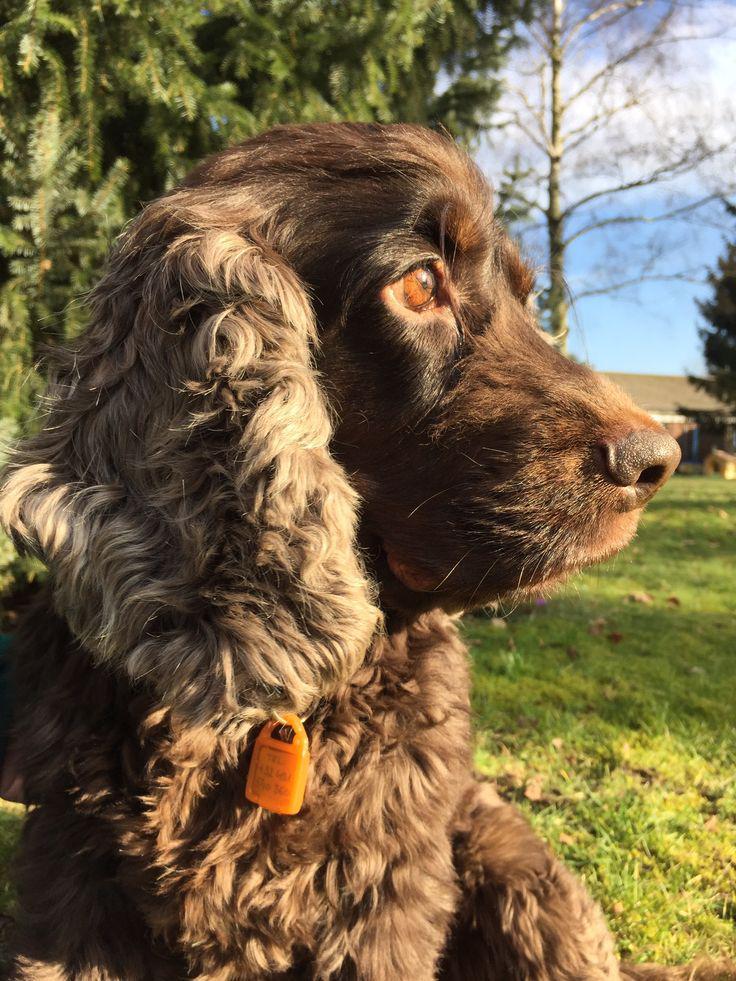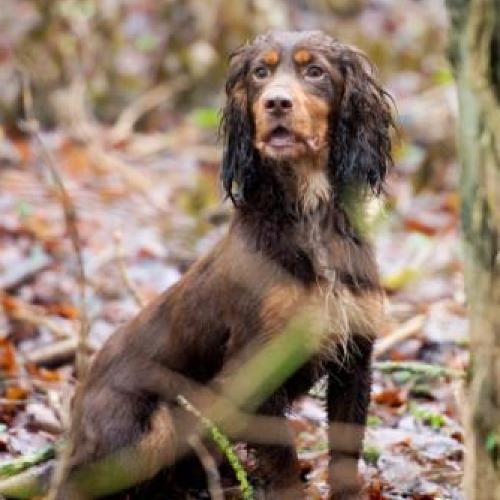The first image is the image on the left, the second image is the image on the right. Given the left and right images, does the statement "One image shows an upright spaniel with bedraggled wet fur, especially on its ears, and the other image shows one spaniel with a coat of dry fur in one color." hold true? Answer yes or no. Yes. The first image is the image on the left, the second image is the image on the right. Evaluate the accuracy of this statement regarding the images: "The dogs in each of the images are situated outside.". Is it true? Answer yes or no. Yes. 